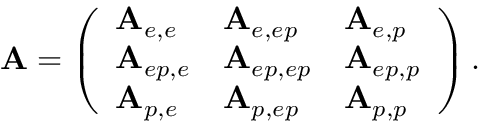Convert formula to latex. <formula><loc_0><loc_0><loc_500><loc_500>A = \left ( \begin{array} { l l l } { A _ { e , e } } & { A _ { e , e p } } & { A _ { e , p } } \\ { A _ { e p , e } } & { A _ { e p , e p } } & { A _ { e p , p } } \\ { A _ { p , e } } & { A _ { p , e p } } & { A _ { p , p } } \end{array} \right ) .</formula> 